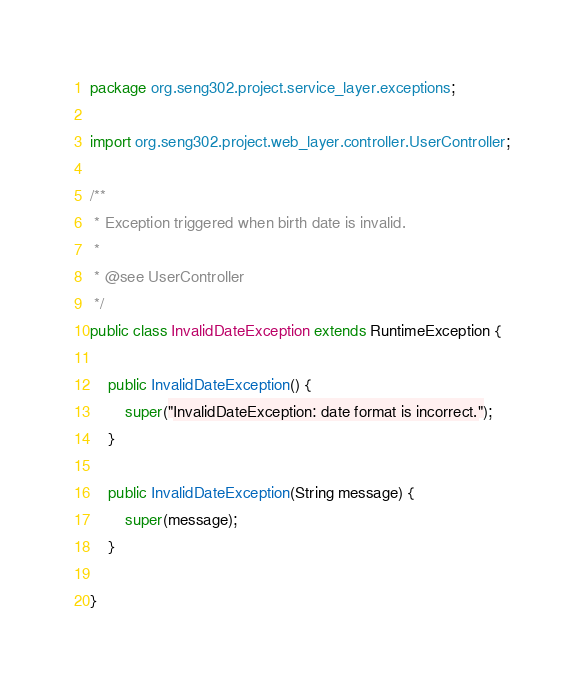Convert code to text. <code><loc_0><loc_0><loc_500><loc_500><_Java_>package org.seng302.project.service_layer.exceptions;

import org.seng302.project.web_layer.controller.UserController;

/**
 * Exception triggered when birth date is invalid.
 *
 * @see UserController
 */
public class InvalidDateException extends RuntimeException {

    public InvalidDateException() {
        super("InvalidDateException: date format is incorrect.");
    }

    public InvalidDateException(String message) {
        super(message);
    }

}
</code> 